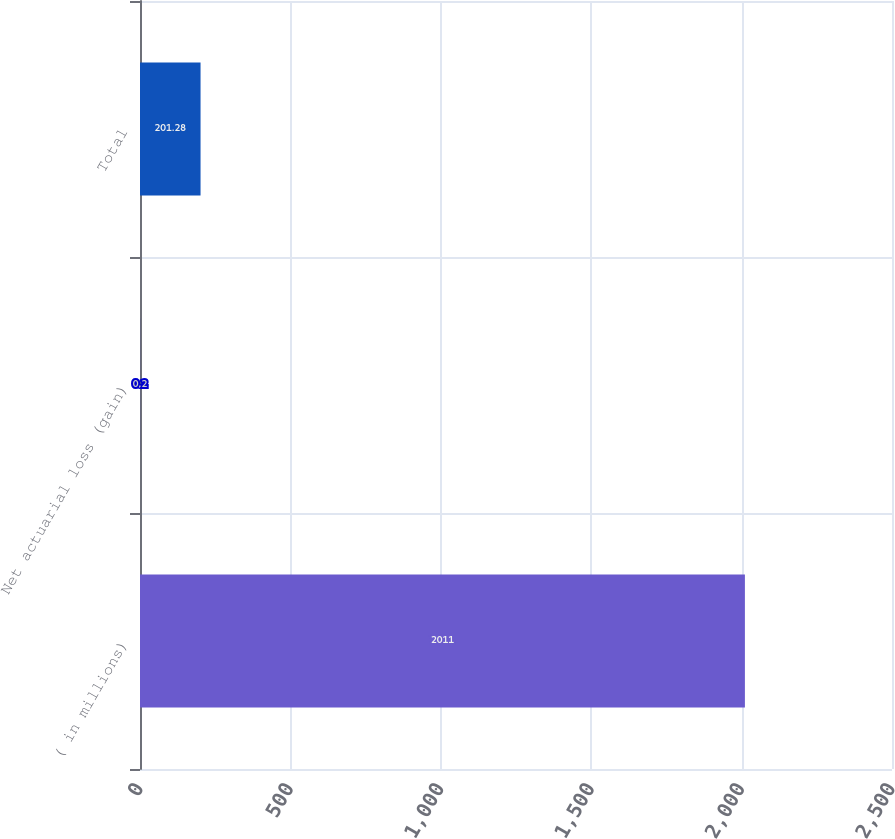Convert chart. <chart><loc_0><loc_0><loc_500><loc_500><bar_chart><fcel>( in millions)<fcel>Net actuarial loss (gain)<fcel>Total<nl><fcel>2011<fcel>0.2<fcel>201.28<nl></chart> 